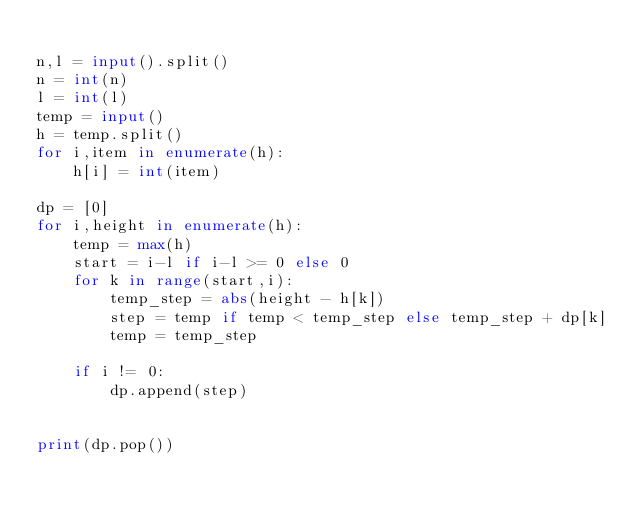Convert code to text. <code><loc_0><loc_0><loc_500><loc_500><_Python_>
n,l = input().split()
n = int(n)
l = int(l)
temp = input()
h = temp.split()
for i,item in enumerate(h):
    h[i] = int(item)

dp = [0]
for i,height in enumerate(h):
    temp = max(h)
    start = i-l if i-l >= 0 else 0
    for k in range(start,i):
        temp_step = abs(height - h[k])
        step = temp if temp < temp_step else temp_step + dp[k]
        temp = temp_step

    if i != 0:
        dp.append(step)


print(dp.pop())


</code> 